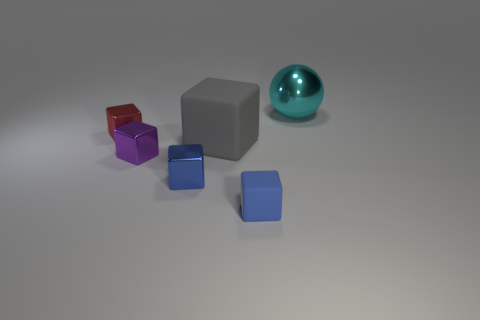The block that is the same color as the small matte object is what size?
Offer a very short reply. Small. There is a rubber cube that is behind the blue block right of the large block; how many metallic cubes are in front of it?
Make the answer very short. 2. Does the blue metallic cube have the same size as the metallic block that is behind the purple shiny thing?
Keep it short and to the point. Yes. How big is the matte block that is on the left side of the tiny matte block in front of the tiny blue shiny object?
Provide a short and direct response. Large. How many cubes are made of the same material as the purple object?
Your answer should be compact. 2. Are there any cyan spheres?
Your answer should be very brief. Yes. There is a metal thing right of the large gray object; what size is it?
Your response must be concise. Large. How many other large blocks have the same color as the large matte cube?
Your response must be concise. 0. How many cylinders are tiny objects or gray matte objects?
Your answer should be compact. 0. What is the shape of the shiny object that is both behind the gray object and to the right of the small red shiny block?
Provide a short and direct response. Sphere. 